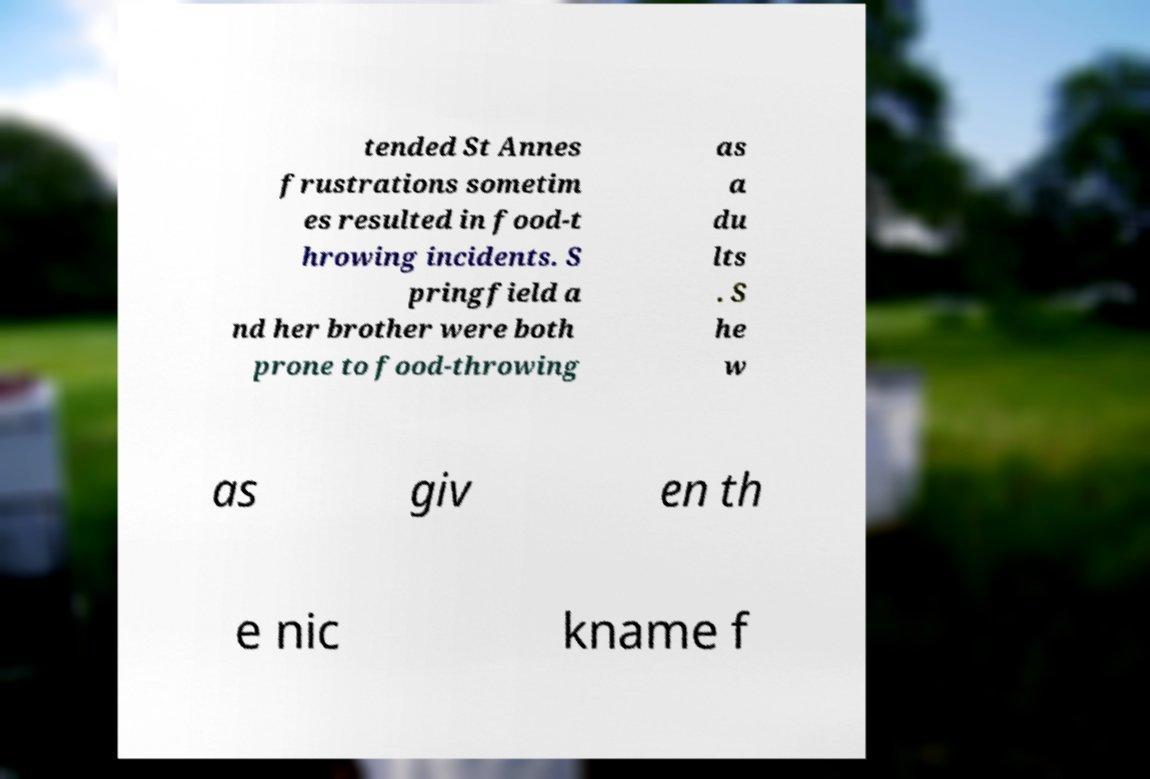Could you extract and type out the text from this image? tended St Annes frustrations sometim es resulted in food-t hrowing incidents. S pringfield a nd her brother were both prone to food-throwing as a du lts . S he w as giv en th e nic kname f 